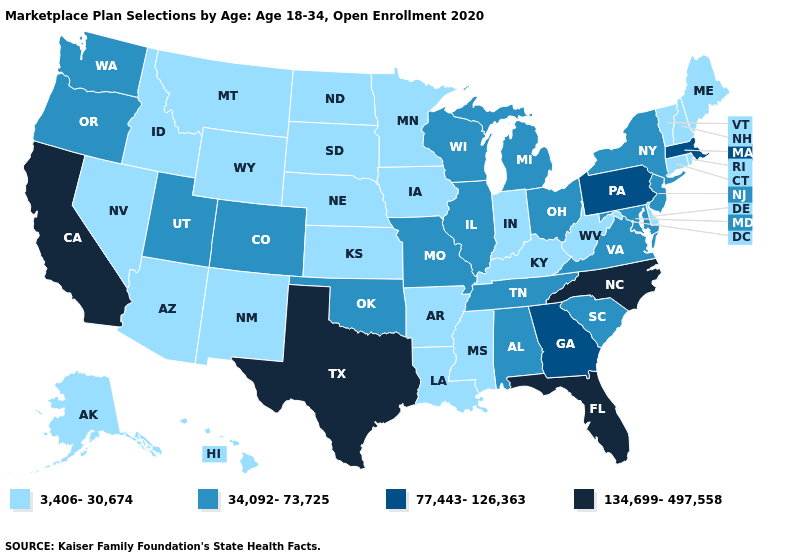Does Wyoming have the same value as West Virginia?
Write a very short answer. Yes. Which states have the lowest value in the MidWest?
Answer briefly. Indiana, Iowa, Kansas, Minnesota, Nebraska, North Dakota, South Dakota. Name the states that have a value in the range 134,699-497,558?
Short answer required. California, Florida, North Carolina, Texas. Does Texas have the highest value in the USA?
Write a very short answer. Yes. What is the value of Minnesota?
Write a very short answer. 3,406-30,674. What is the value of Tennessee?
Short answer required. 34,092-73,725. Among the states that border Ohio , which have the highest value?
Give a very brief answer. Pennsylvania. Does the map have missing data?
Be succinct. No. What is the highest value in the West ?
Keep it brief. 134,699-497,558. What is the value of Georgia?
Answer briefly. 77,443-126,363. Name the states that have a value in the range 34,092-73,725?
Answer briefly. Alabama, Colorado, Illinois, Maryland, Michigan, Missouri, New Jersey, New York, Ohio, Oklahoma, Oregon, South Carolina, Tennessee, Utah, Virginia, Washington, Wisconsin. Does Washington have a higher value than South Dakota?
Write a very short answer. Yes. What is the lowest value in states that border West Virginia?
Give a very brief answer. 3,406-30,674. Which states have the lowest value in the Northeast?
Short answer required. Connecticut, Maine, New Hampshire, Rhode Island, Vermont. Is the legend a continuous bar?
Be succinct. No. 